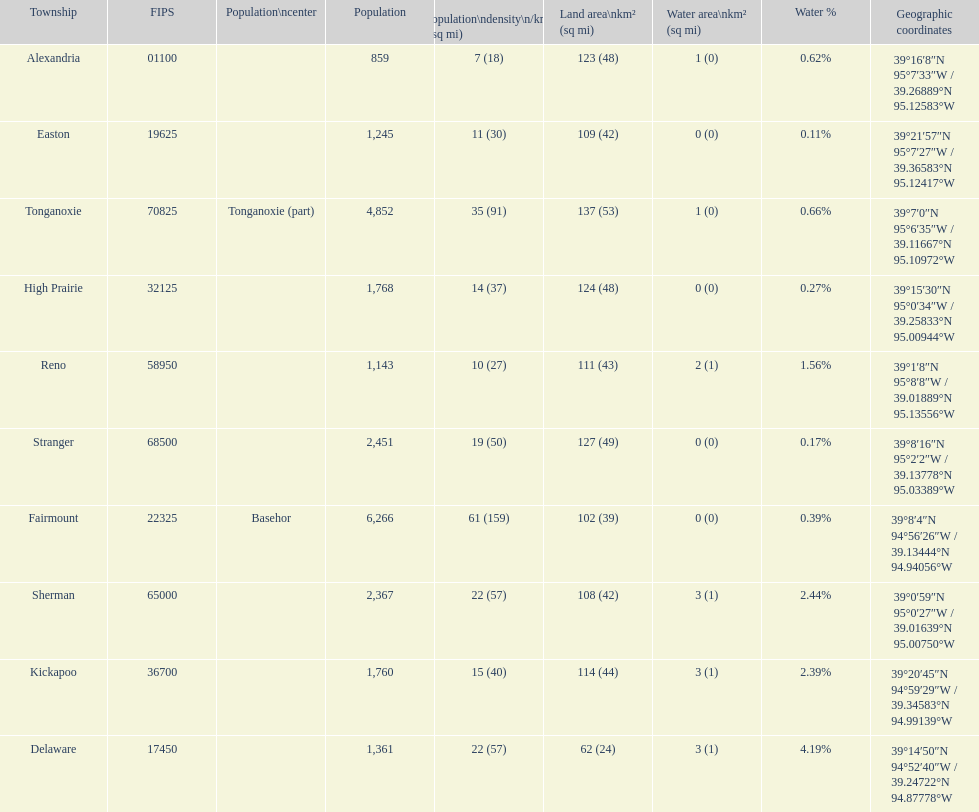How many townships are in leavenworth county? 10. 